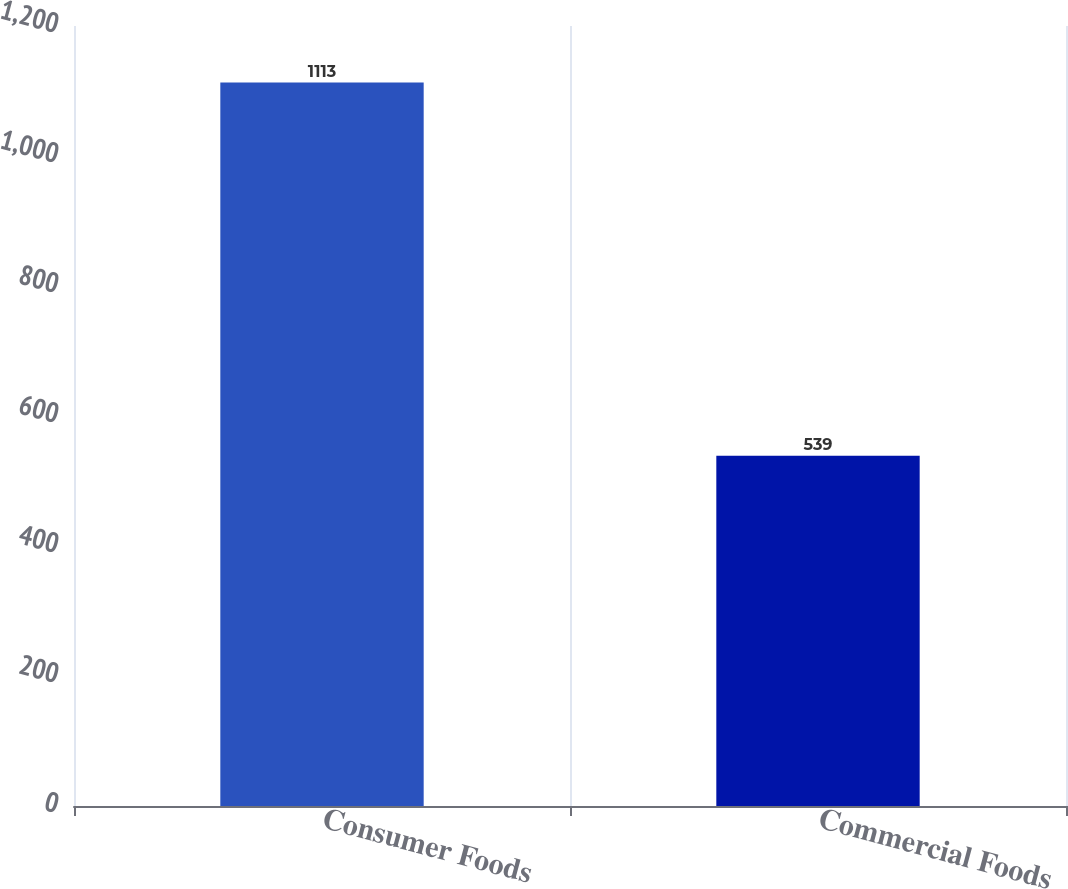<chart> <loc_0><loc_0><loc_500><loc_500><bar_chart><fcel>Consumer Foods<fcel>Commercial Foods<nl><fcel>1113<fcel>539<nl></chart> 